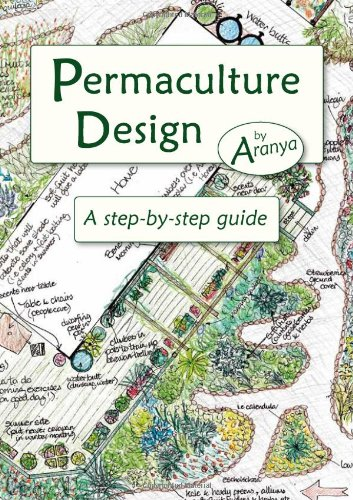Is this book related to Science Fiction & Fantasy? No, this book is purely educational and practical, focusing on real-world applications of permaculture design, which distinguishes it from the realms of Science Fiction & Fantasy. 